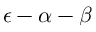Convert formula to latex. <formula><loc_0><loc_0><loc_500><loc_500>\epsilon - \alpha - \beta</formula> 